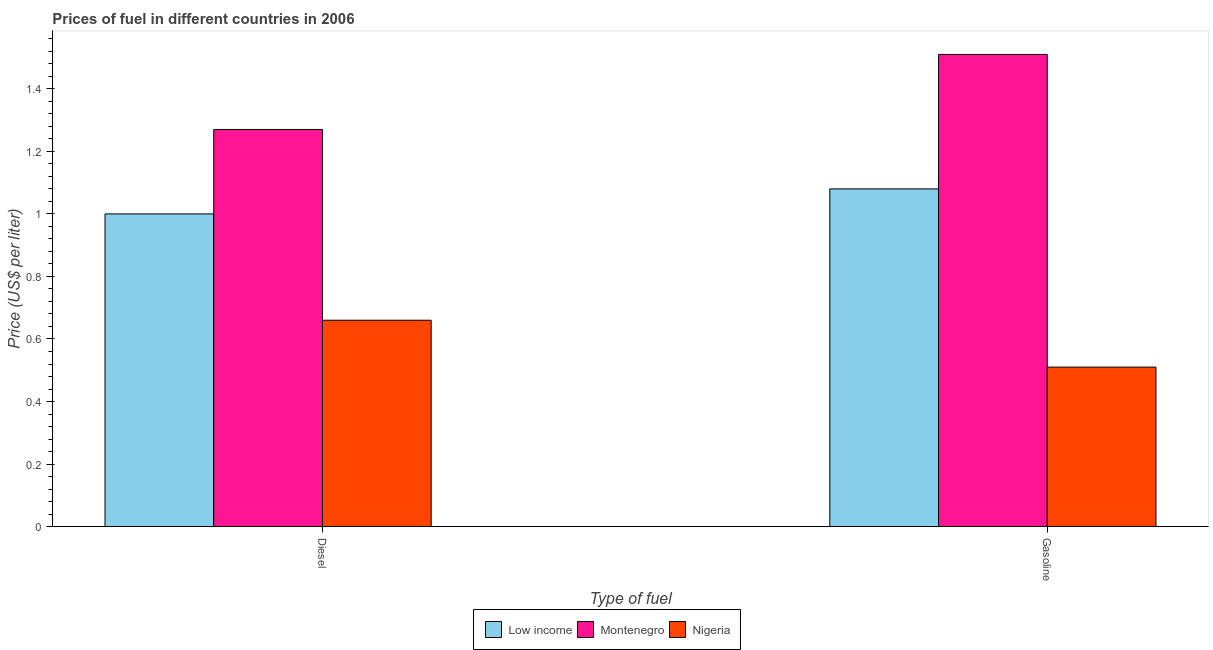How many groups of bars are there?
Your answer should be very brief. 2. Are the number of bars per tick equal to the number of legend labels?
Provide a succinct answer. Yes. What is the label of the 2nd group of bars from the left?
Offer a terse response. Gasoline. What is the diesel price in Low income?
Offer a terse response. 1. Across all countries, what is the maximum diesel price?
Offer a terse response. 1.27. Across all countries, what is the minimum diesel price?
Your answer should be compact. 0.66. In which country was the gasoline price maximum?
Keep it short and to the point. Montenegro. In which country was the gasoline price minimum?
Provide a short and direct response. Nigeria. What is the total diesel price in the graph?
Your answer should be compact. 2.93. What is the difference between the gasoline price in Low income and that in Montenegro?
Your answer should be compact. -0.43. What is the difference between the diesel price in Montenegro and the gasoline price in Low income?
Keep it short and to the point. 0.19. What is the average gasoline price per country?
Provide a short and direct response. 1.03. What is the difference between the gasoline price and diesel price in Nigeria?
Your answer should be very brief. -0.15. What is the ratio of the gasoline price in Low income to that in Nigeria?
Give a very brief answer. 2.12. Is the gasoline price in Low income less than that in Montenegro?
Make the answer very short. Yes. What does the 2nd bar from the left in Diesel represents?
Ensure brevity in your answer.  Montenegro. What does the 3rd bar from the right in Diesel represents?
Your answer should be very brief. Low income. How many bars are there?
Provide a succinct answer. 6. Are all the bars in the graph horizontal?
Offer a terse response. No. How many countries are there in the graph?
Offer a terse response. 3. What is the difference between two consecutive major ticks on the Y-axis?
Offer a very short reply. 0.2. Does the graph contain any zero values?
Give a very brief answer. No. Does the graph contain grids?
Give a very brief answer. No. Where does the legend appear in the graph?
Offer a terse response. Bottom center. What is the title of the graph?
Your answer should be compact. Prices of fuel in different countries in 2006. What is the label or title of the X-axis?
Your response must be concise. Type of fuel. What is the label or title of the Y-axis?
Ensure brevity in your answer.  Price (US$ per liter). What is the Price (US$ per liter) in Low income in Diesel?
Offer a terse response. 1. What is the Price (US$ per liter) in Montenegro in Diesel?
Provide a succinct answer. 1.27. What is the Price (US$ per liter) of Nigeria in Diesel?
Keep it short and to the point. 0.66. What is the Price (US$ per liter) in Montenegro in Gasoline?
Offer a very short reply. 1.51. What is the Price (US$ per liter) in Nigeria in Gasoline?
Your response must be concise. 0.51. Across all Type of fuel, what is the maximum Price (US$ per liter) in Montenegro?
Provide a succinct answer. 1.51. Across all Type of fuel, what is the maximum Price (US$ per liter) of Nigeria?
Make the answer very short. 0.66. Across all Type of fuel, what is the minimum Price (US$ per liter) in Montenegro?
Ensure brevity in your answer.  1.27. Across all Type of fuel, what is the minimum Price (US$ per liter) of Nigeria?
Give a very brief answer. 0.51. What is the total Price (US$ per liter) of Low income in the graph?
Ensure brevity in your answer.  2.08. What is the total Price (US$ per liter) in Montenegro in the graph?
Give a very brief answer. 2.78. What is the total Price (US$ per liter) of Nigeria in the graph?
Keep it short and to the point. 1.17. What is the difference between the Price (US$ per liter) in Low income in Diesel and that in Gasoline?
Make the answer very short. -0.08. What is the difference between the Price (US$ per liter) of Montenegro in Diesel and that in Gasoline?
Provide a short and direct response. -0.24. What is the difference between the Price (US$ per liter) in Low income in Diesel and the Price (US$ per liter) in Montenegro in Gasoline?
Provide a succinct answer. -0.51. What is the difference between the Price (US$ per liter) of Low income in Diesel and the Price (US$ per liter) of Nigeria in Gasoline?
Offer a very short reply. 0.49. What is the difference between the Price (US$ per liter) in Montenegro in Diesel and the Price (US$ per liter) in Nigeria in Gasoline?
Keep it short and to the point. 0.76. What is the average Price (US$ per liter) in Montenegro per Type of fuel?
Your response must be concise. 1.39. What is the average Price (US$ per liter) of Nigeria per Type of fuel?
Offer a very short reply. 0.58. What is the difference between the Price (US$ per liter) of Low income and Price (US$ per liter) of Montenegro in Diesel?
Your response must be concise. -0.27. What is the difference between the Price (US$ per liter) of Low income and Price (US$ per liter) of Nigeria in Diesel?
Offer a very short reply. 0.34. What is the difference between the Price (US$ per liter) in Montenegro and Price (US$ per liter) in Nigeria in Diesel?
Provide a short and direct response. 0.61. What is the difference between the Price (US$ per liter) of Low income and Price (US$ per liter) of Montenegro in Gasoline?
Your response must be concise. -0.43. What is the difference between the Price (US$ per liter) in Low income and Price (US$ per liter) in Nigeria in Gasoline?
Provide a short and direct response. 0.57. What is the ratio of the Price (US$ per liter) of Low income in Diesel to that in Gasoline?
Your answer should be compact. 0.93. What is the ratio of the Price (US$ per liter) of Montenegro in Diesel to that in Gasoline?
Your answer should be very brief. 0.84. What is the ratio of the Price (US$ per liter) in Nigeria in Diesel to that in Gasoline?
Provide a short and direct response. 1.29. What is the difference between the highest and the second highest Price (US$ per liter) in Low income?
Make the answer very short. 0.08. What is the difference between the highest and the second highest Price (US$ per liter) of Montenegro?
Your response must be concise. 0.24. What is the difference between the highest and the lowest Price (US$ per liter) in Montenegro?
Provide a short and direct response. 0.24. 